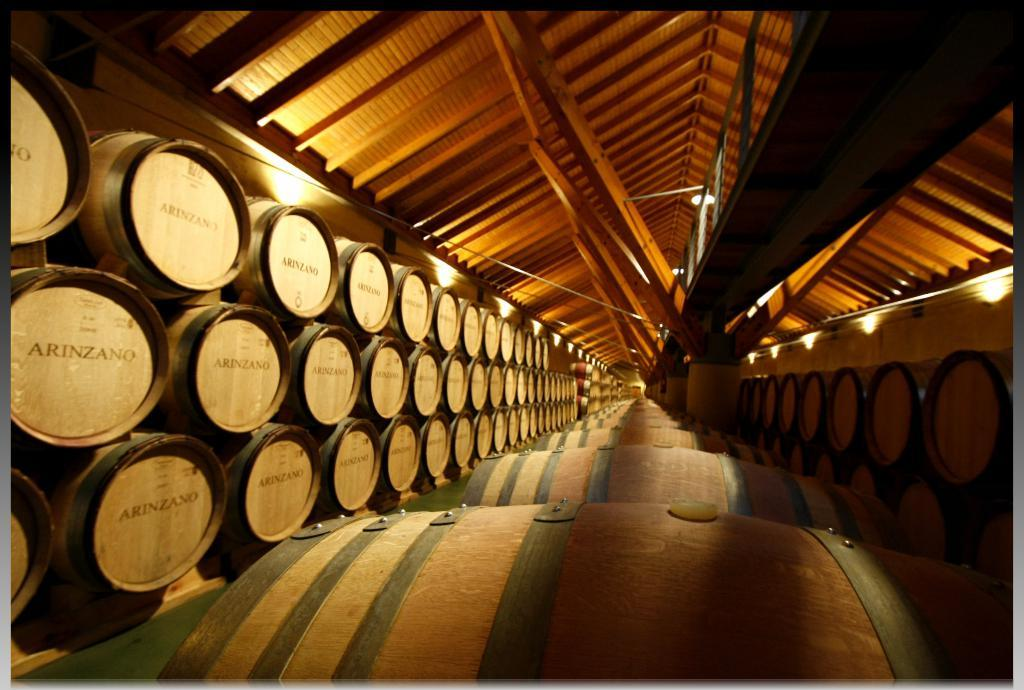<image>
Create a compact narrative representing the image presented. Many barrels of Arinzano are lined up in a building. 